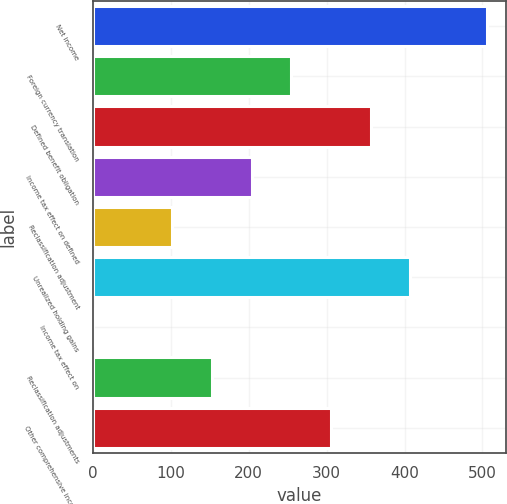Convert chart to OTSL. <chart><loc_0><loc_0><loc_500><loc_500><bar_chart><fcel>Net income<fcel>Foreign currency translation<fcel>Defined benefit obligation<fcel>Income tax effect on defined<fcel>Reclassification adjustment<fcel>Unrealized holding gains<fcel>Income tax effect on<fcel>Reclassification adjustments<fcel>Other comprehensive income<nl><fcel>505.3<fcel>254.65<fcel>356.43<fcel>203.76<fcel>101.98<fcel>407.32<fcel>0.2<fcel>152.87<fcel>305.54<nl></chart> 